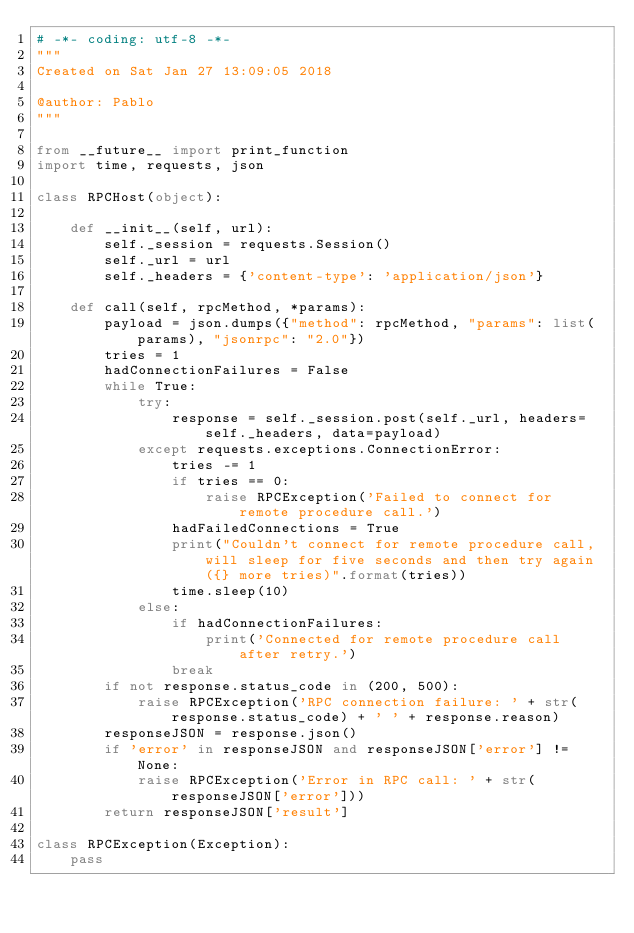<code> <loc_0><loc_0><loc_500><loc_500><_Python_># -*- coding: utf-8 -*-
"""
Created on Sat Jan 27 13:09:05 2018

@author: Pablo
"""

from __future__ import print_function
import time, requests, json

class RPCHost(object):
    
    def __init__(self, url):
        self._session = requests.Session()
        self._url = url
        self._headers = {'content-type': 'application/json'}
        
    def call(self, rpcMethod, *params):
        payload = json.dumps({"method": rpcMethod, "params": list(params), "jsonrpc": "2.0"})
        tries = 1
        hadConnectionFailures = False
        while True:
            try:
                response = self._session.post(self._url, headers=self._headers, data=payload)
            except requests.exceptions.ConnectionError:
                tries -= 1
                if tries == 0:
                    raise RPCException('Failed to connect for remote procedure call.')
                hadFailedConnections = True
                print("Couldn't connect for remote procedure call, will sleep for five seconds and then try again ({} more tries)".format(tries))
                time.sleep(10)
            else:
                if hadConnectionFailures:
                    print('Connected for remote procedure call after retry.')
                break
        if not response.status_code in (200, 500):
            raise RPCException('RPC connection failure: ' + str(response.status_code) + ' ' + response.reason)
        responseJSON = response.json()
        if 'error' in responseJSON and responseJSON['error'] != None:
            raise RPCException('Error in RPC call: ' + str(responseJSON['error']))
        return responseJSON['result']
    
class RPCException(Exception):
    pass</code> 